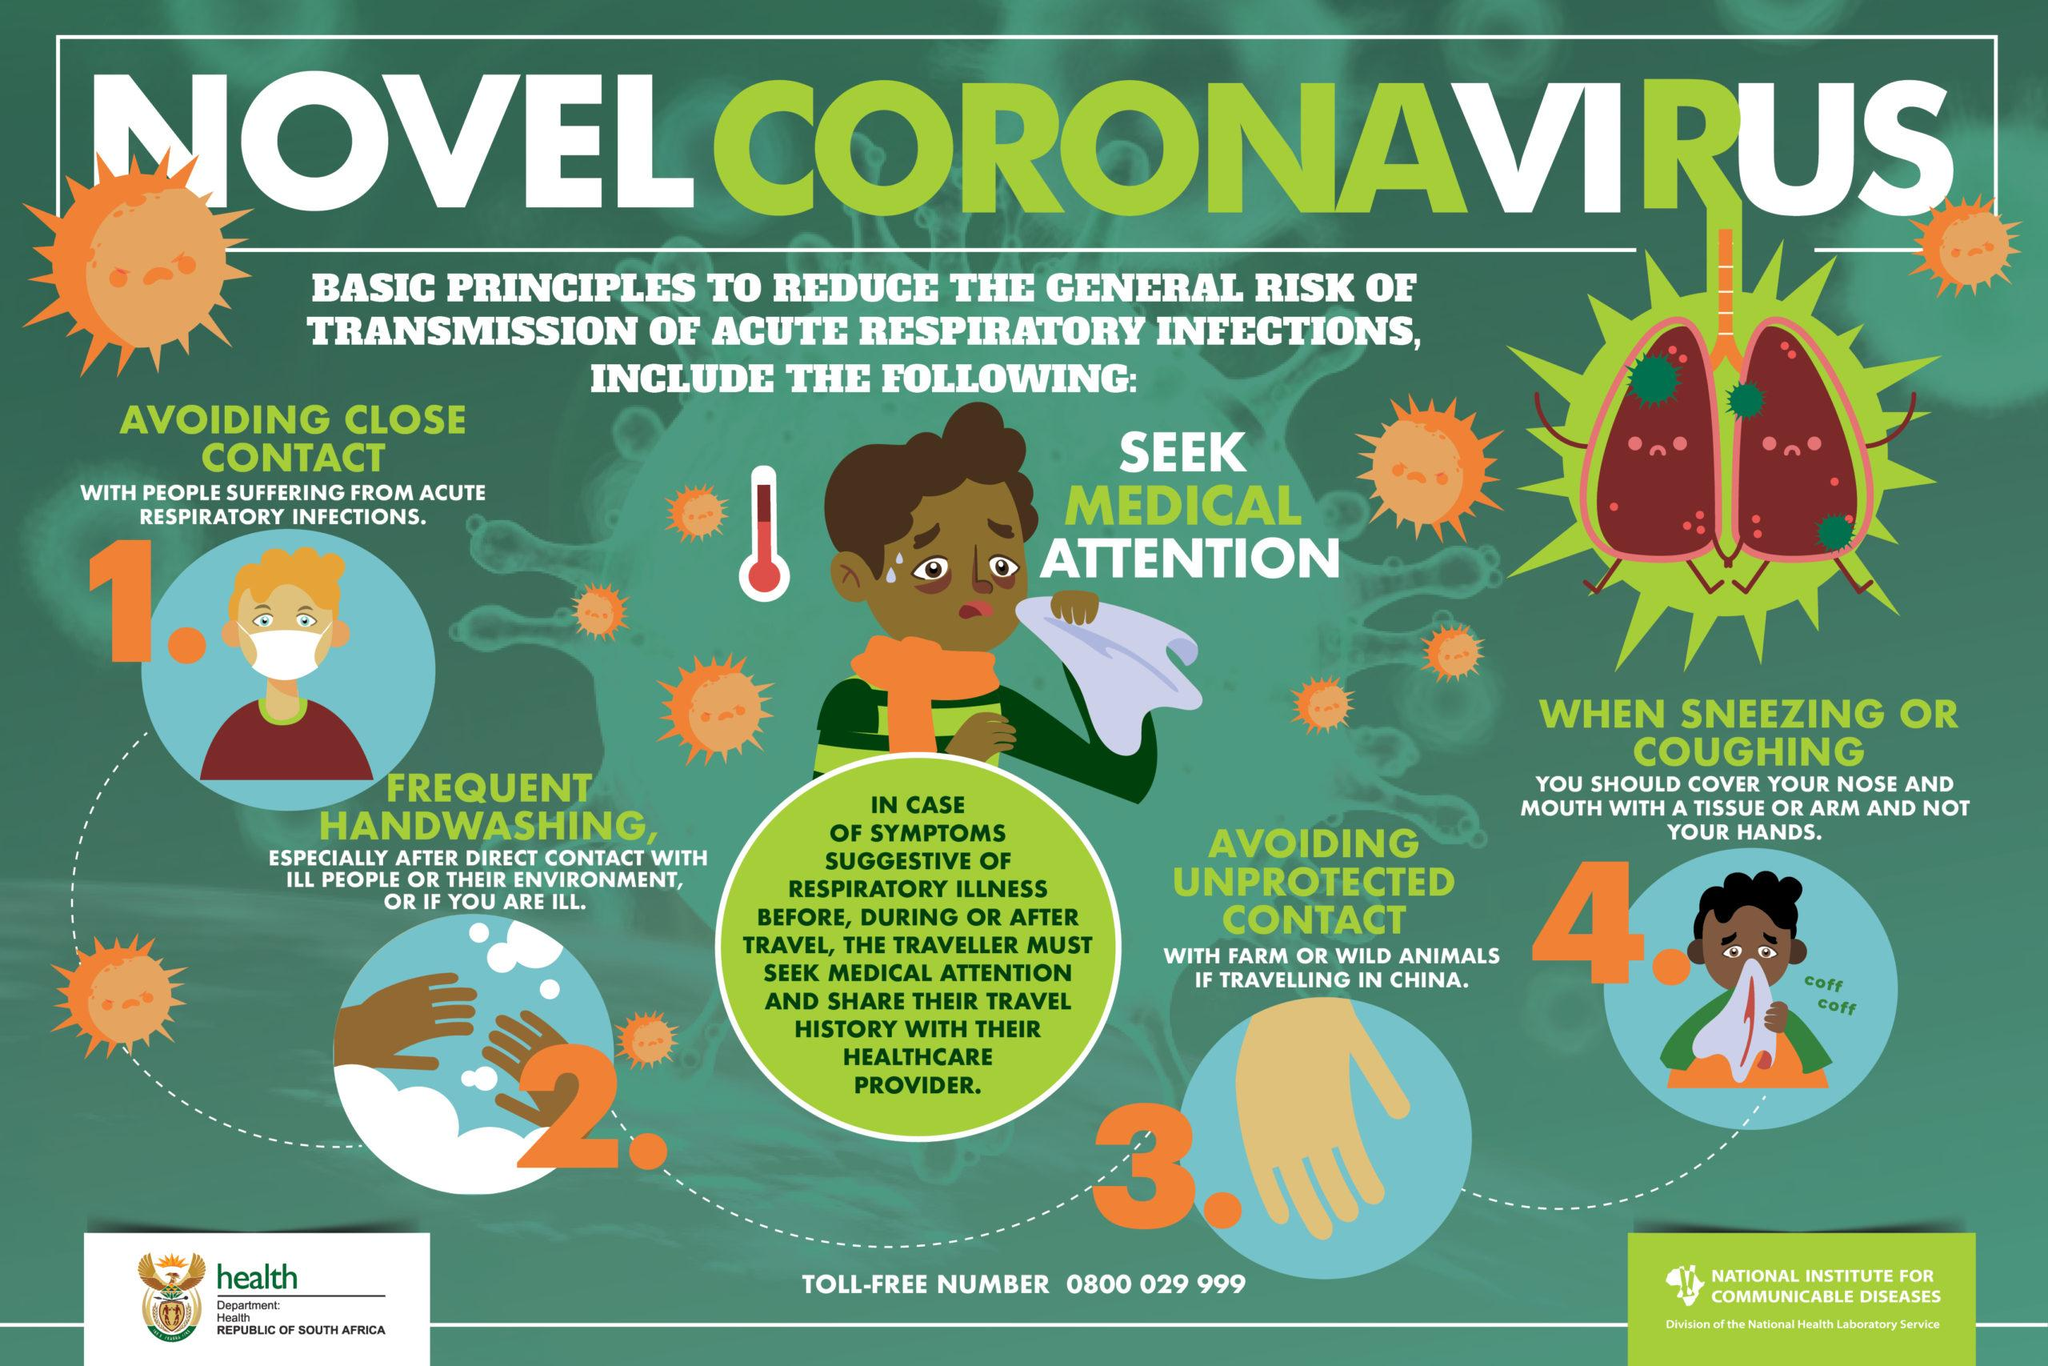Outline some significant characteristics in this image. If a traveler is experiencing symptoms of respiratory illness, they should seek immediate medical attention and provide their healthcare provider with their travel history. After direct contact with ill people or their environment, it is essential to follow the general principle of frequent handwashing to prevent the spread of infection. It is appropriate to cover your nose and mouth with a tissue when sneezing or coughing in order to help prevent the spread of illness. The first principle for reducing the general risk of transmission of acute respiratory infections is to avoid close contact with individuals who are ill. It is crucial to avoid unprotected contact with farm or wild animals to ensure personal safety. 